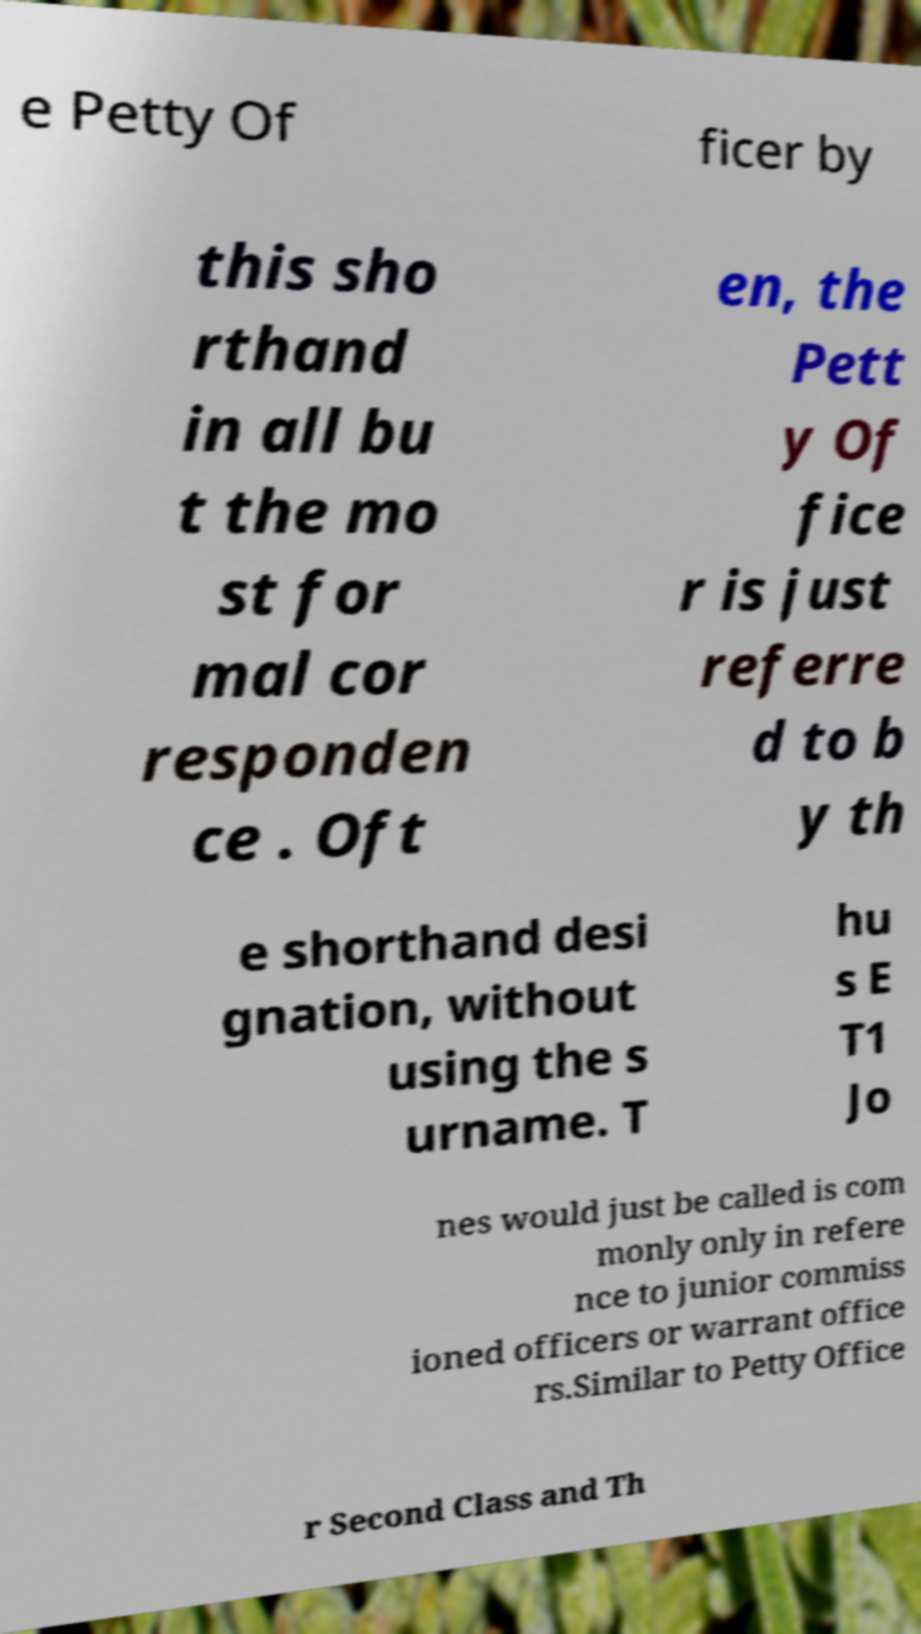Can you accurately transcribe the text from the provided image for me? e Petty Of ficer by this sho rthand in all bu t the mo st for mal cor responden ce . Oft en, the Pett y Of fice r is just referre d to b y th e shorthand desi gnation, without using the s urname. T hu s E T1 Jo nes would just be called is com monly only in refere nce to junior commiss ioned officers or warrant office rs.Similar to Petty Office r Second Class and Th 